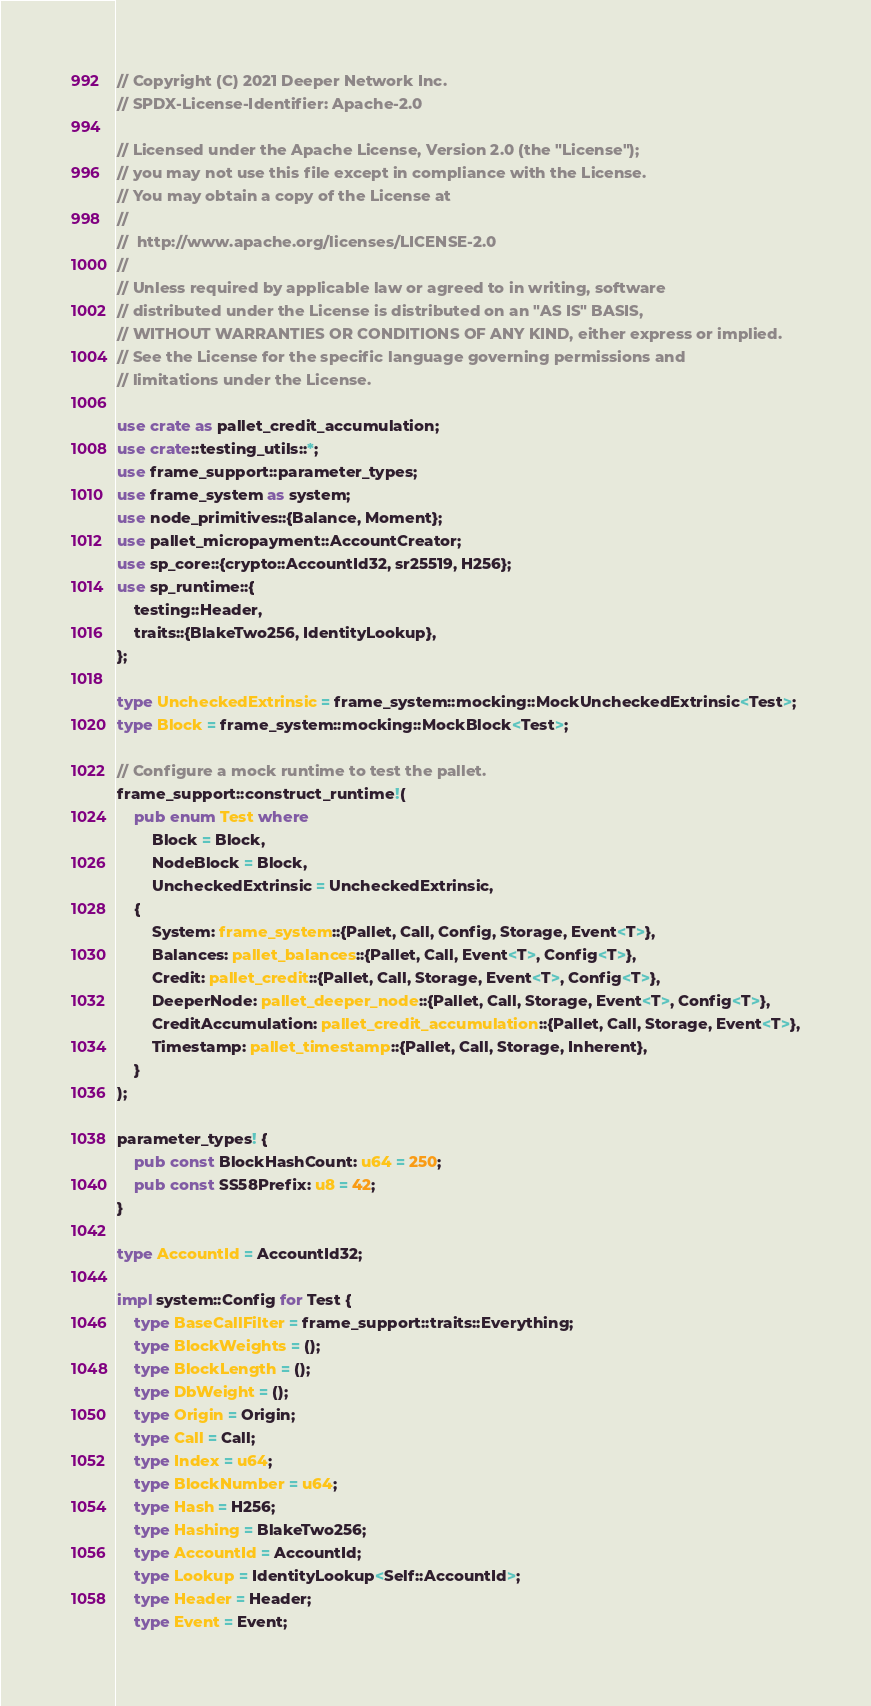<code> <loc_0><loc_0><loc_500><loc_500><_Rust_>// Copyright (C) 2021 Deeper Network Inc.
// SPDX-License-Identifier: Apache-2.0

// Licensed under the Apache License, Version 2.0 (the "License");
// you may not use this file except in compliance with the License.
// You may obtain a copy of the License at
//
// 	http://www.apache.org/licenses/LICENSE-2.0
//
// Unless required by applicable law or agreed to in writing, software
// distributed under the License is distributed on an "AS IS" BASIS,
// WITHOUT WARRANTIES OR CONDITIONS OF ANY KIND, either express or implied.
// See the License for the specific language governing permissions and
// limitations under the License.

use crate as pallet_credit_accumulation;
use crate::testing_utils::*;
use frame_support::parameter_types;
use frame_system as system;
use node_primitives::{Balance, Moment};
use pallet_micropayment::AccountCreator;
use sp_core::{crypto::AccountId32, sr25519, H256};
use sp_runtime::{
    testing::Header,
    traits::{BlakeTwo256, IdentityLookup},
};

type UncheckedExtrinsic = frame_system::mocking::MockUncheckedExtrinsic<Test>;
type Block = frame_system::mocking::MockBlock<Test>;

// Configure a mock runtime to test the pallet.
frame_support::construct_runtime!(
    pub enum Test where
        Block = Block,
        NodeBlock = Block,
        UncheckedExtrinsic = UncheckedExtrinsic,
    {
        System: frame_system::{Pallet, Call, Config, Storage, Event<T>},
        Balances: pallet_balances::{Pallet, Call, Event<T>, Config<T>},
        Credit: pallet_credit::{Pallet, Call, Storage, Event<T>, Config<T>},
        DeeperNode: pallet_deeper_node::{Pallet, Call, Storage, Event<T>, Config<T>},
        CreditAccumulation: pallet_credit_accumulation::{Pallet, Call, Storage, Event<T>},
        Timestamp: pallet_timestamp::{Pallet, Call, Storage, Inherent},
    }
);

parameter_types! {
    pub const BlockHashCount: u64 = 250;
    pub const SS58Prefix: u8 = 42;
}

type AccountId = AccountId32;

impl system::Config for Test {
    type BaseCallFilter = frame_support::traits::Everything;
    type BlockWeights = ();
    type BlockLength = ();
    type DbWeight = ();
    type Origin = Origin;
    type Call = Call;
    type Index = u64;
    type BlockNumber = u64;
    type Hash = H256;
    type Hashing = BlakeTwo256;
    type AccountId = AccountId;
    type Lookup = IdentityLookup<Self::AccountId>;
    type Header = Header;
    type Event = Event;</code> 